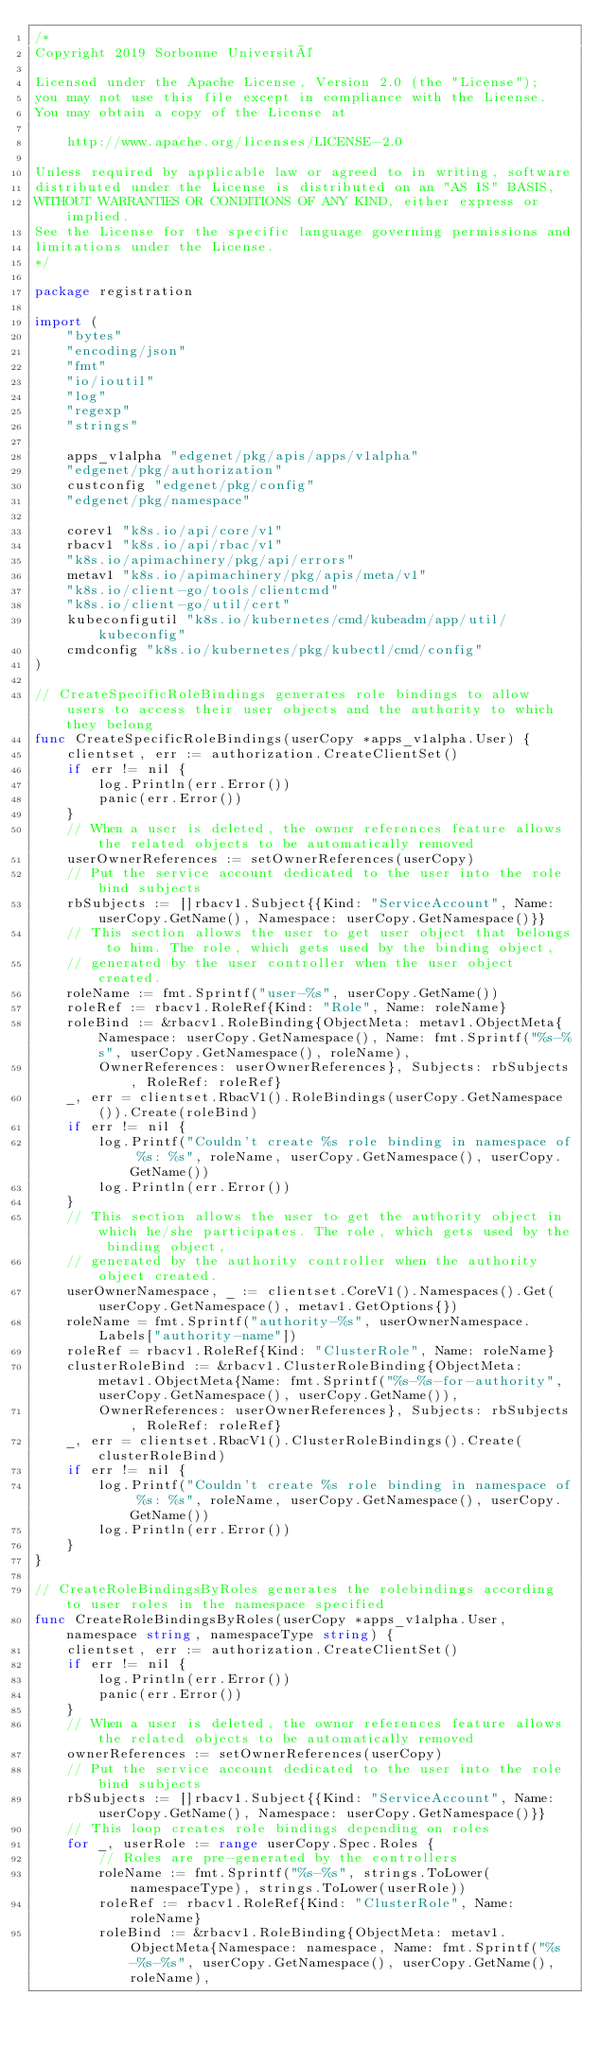Convert code to text. <code><loc_0><loc_0><loc_500><loc_500><_Go_>/*
Copyright 2019 Sorbonne Université

Licensed under the Apache License, Version 2.0 (the "License");
you may not use this file except in compliance with the License.
You may obtain a copy of the License at

    http://www.apache.org/licenses/LICENSE-2.0

Unless required by applicable law or agreed to in writing, software
distributed under the License is distributed on an "AS IS" BASIS,
WITHOUT WARRANTIES OR CONDITIONS OF ANY KIND, either express or implied.
See the License for the specific language governing permissions and
limitations under the License.
*/

package registration

import (
	"bytes"
	"encoding/json"
	"fmt"
	"io/ioutil"
	"log"
	"regexp"
	"strings"

	apps_v1alpha "edgenet/pkg/apis/apps/v1alpha"
	"edgenet/pkg/authorization"
	custconfig "edgenet/pkg/config"
	"edgenet/pkg/namespace"

	corev1 "k8s.io/api/core/v1"
	rbacv1 "k8s.io/api/rbac/v1"
	"k8s.io/apimachinery/pkg/api/errors"
	metav1 "k8s.io/apimachinery/pkg/apis/meta/v1"
	"k8s.io/client-go/tools/clientcmd"
	"k8s.io/client-go/util/cert"
	kubeconfigutil "k8s.io/kubernetes/cmd/kubeadm/app/util/kubeconfig"
	cmdconfig "k8s.io/kubernetes/pkg/kubectl/cmd/config"
)

// CreateSpecificRoleBindings generates role bindings to allow users to access their user objects and the authority to which they belong
func CreateSpecificRoleBindings(userCopy *apps_v1alpha.User) {
	clientset, err := authorization.CreateClientSet()
	if err != nil {
		log.Println(err.Error())
		panic(err.Error())
	}
	// When a user is deleted, the owner references feature allows the related objects to be automatically removed
	userOwnerReferences := setOwnerReferences(userCopy)
	// Put the service account dedicated to the user into the role bind subjects
	rbSubjects := []rbacv1.Subject{{Kind: "ServiceAccount", Name: userCopy.GetName(), Namespace: userCopy.GetNamespace()}}
	// This section allows the user to get user object that belongs to him. The role, which gets used by the binding object,
	// generated by the user controller when the user object created.
	roleName := fmt.Sprintf("user-%s", userCopy.GetName())
	roleRef := rbacv1.RoleRef{Kind: "Role", Name: roleName}
	roleBind := &rbacv1.RoleBinding{ObjectMeta: metav1.ObjectMeta{Namespace: userCopy.GetNamespace(), Name: fmt.Sprintf("%s-%s", userCopy.GetNamespace(), roleName),
		OwnerReferences: userOwnerReferences}, Subjects: rbSubjects, RoleRef: roleRef}
	_, err = clientset.RbacV1().RoleBindings(userCopy.GetNamespace()).Create(roleBind)
	if err != nil {
		log.Printf("Couldn't create %s role binding in namespace of %s: %s", roleName, userCopy.GetNamespace(), userCopy.GetName())
		log.Println(err.Error())
	}
	// This section allows the user to get the authority object in which he/she participates. The role, which gets used by the binding object,
	// generated by the authority controller when the authority object created.
	userOwnerNamespace, _ := clientset.CoreV1().Namespaces().Get(userCopy.GetNamespace(), metav1.GetOptions{})
	roleName = fmt.Sprintf("authority-%s", userOwnerNamespace.Labels["authority-name"])
	roleRef = rbacv1.RoleRef{Kind: "ClusterRole", Name: roleName}
	clusterRoleBind := &rbacv1.ClusterRoleBinding{ObjectMeta: metav1.ObjectMeta{Name: fmt.Sprintf("%s-%s-for-authority", userCopy.GetNamespace(), userCopy.GetName()),
		OwnerReferences: userOwnerReferences}, Subjects: rbSubjects, RoleRef: roleRef}
	_, err = clientset.RbacV1().ClusterRoleBindings().Create(clusterRoleBind)
	if err != nil {
		log.Printf("Couldn't create %s role binding in namespace of %s: %s", roleName, userCopy.GetNamespace(), userCopy.GetName())
		log.Println(err.Error())
	}
}

// CreateRoleBindingsByRoles generates the rolebindings according to user roles in the namespace specified
func CreateRoleBindingsByRoles(userCopy *apps_v1alpha.User, namespace string, namespaceType string) {
	clientset, err := authorization.CreateClientSet()
	if err != nil {
		log.Println(err.Error())
		panic(err.Error())
	}
	// When a user is deleted, the owner references feature allows the related objects to be automatically removed
	ownerReferences := setOwnerReferences(userCopy)
	// Put the service account dedicated to the user into the role bind subjects
	rbSubjects := []rbacv1.Subject{{Kind: "ServiceAccount", Name: userCopy.GetName(), Namespace: userCopy.GetNamespace()}}
	// This loop creates role bindings depending on roles
	for _, userRole := range userCopy.Spec.Roles {
		// Roles are pre-generated by the controllers
		roleName := fmt.Sprintf("%s-%s", strings.ToLower(namespaceType), strings.ToLower(userRole))
		roleRef := rbacv1.RoleRef{Kind: "ClusterRole", Name: roleName}
		roleBind := &rbacv1.RoleBinding{ObjectMeta: metav1.ObjectMeta{Namespace: namespace, Name: fmt.Sprintf("%s-%s-%s", userCopy.GetNamespace(), userCopy.GetName(), roleName),</code> 